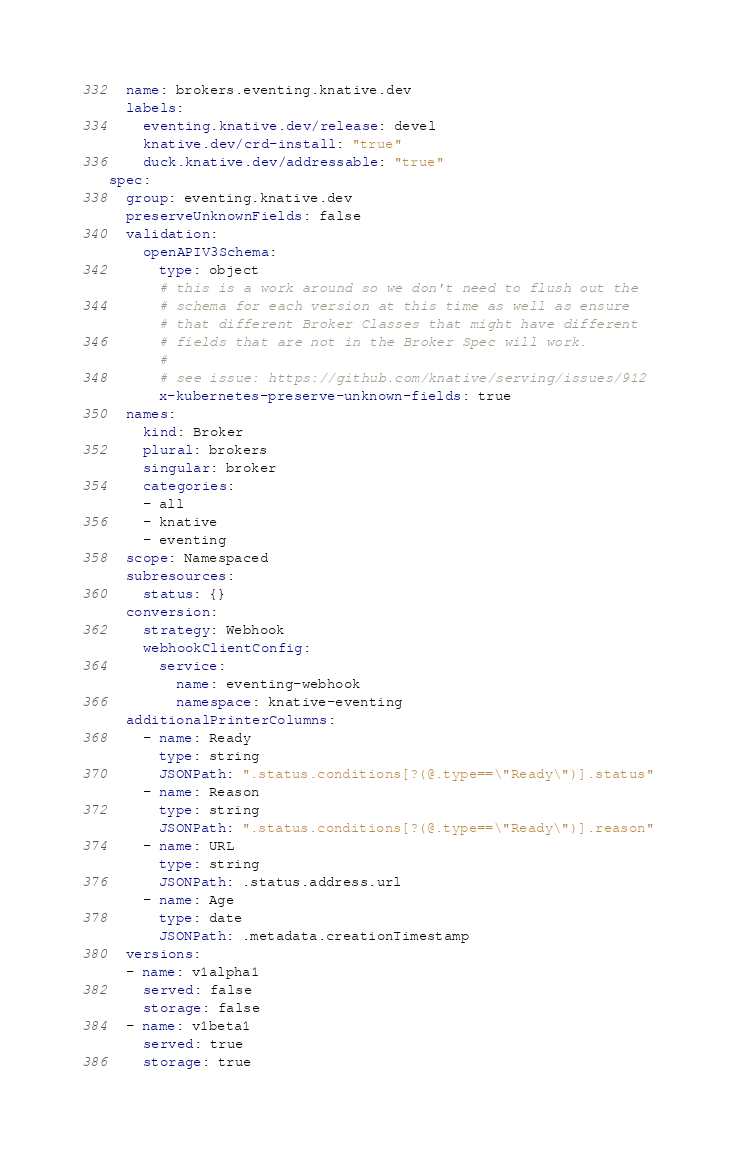<code> <loc_0><loc_0><loc_500><loc_500><_YAML_>  name: brokers.eventing.knative.dev
  labels:
    eventing.knative.dev/release: devel
    knative.dev/crd-install: "true"
    duck.knative.dev/addressable: "true"
spec:
  group: eventing.knative.dev
  preserveUnknownFields: false
  validation:
    openAPIV3Schema:
      type: object
      # this is a work around so we don't need to flush out the
      # schema for each version at this time as well as ensure
      # that different Broker Classes that might have different
      # fields that are not in the Broker Spec will work.
      #
      # see issue: https://github.com/knative/serving/issues/912
      x-kubernetes-preserve-unknown-fields: true
  names:
    kind: Broker
    plural: brokers
    singular: broker
    categories:
    - all
    - knative
    - eventing
  scope: Namespaced
  subresources:
    status: {}
  conversion:
    strategy: Webhook
    webhookClientConfig:
      service:
        name: eventing-webhook
        namespace: knative-eventing
  additionalPrinterColumns:
    - name: Ready
      type: string
      JSONPath: ".status.conditions[?(@.type==\"Ready\")].status"
    - name: Reason
      type: string
      JSONPath: ".status.conditions[?(@.type==\"Ready\")].reason"
    - name: URL
      type: string
      JSONPath: .status.address.url
    - name: Age
      type: date
      JSONPath: .metadata.creationTimestamp
  versions:
  - name: v1alpha1
    served: false
    storage: false
  - name: v1beta1
    served: true
    storage: true
</code> 